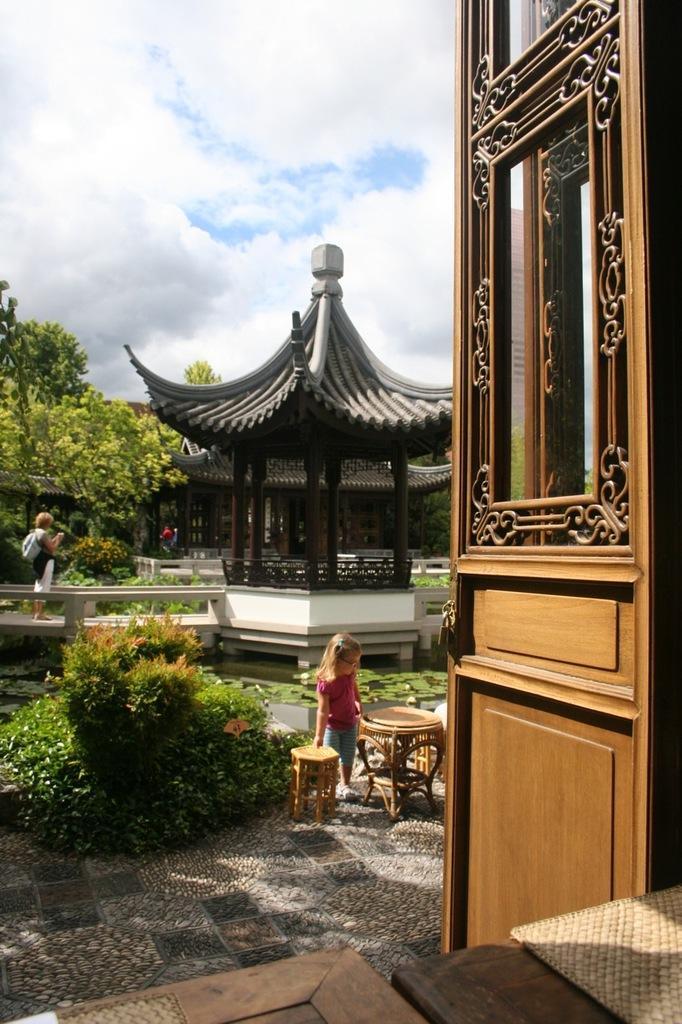Describe this image in one or two sentences. In this picture we can see a kid is standing in the front, there are some plants and water in the middle, on the left side there is a person standing, in the background there are some trees, we can also see a shelter in the background, there is the sky and clouds at the top of the picture, there are two tables in the front. 